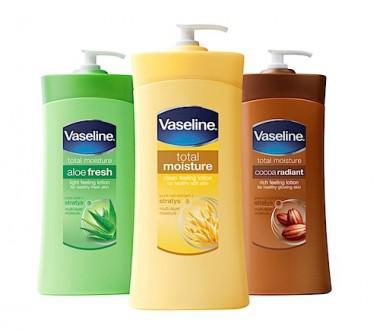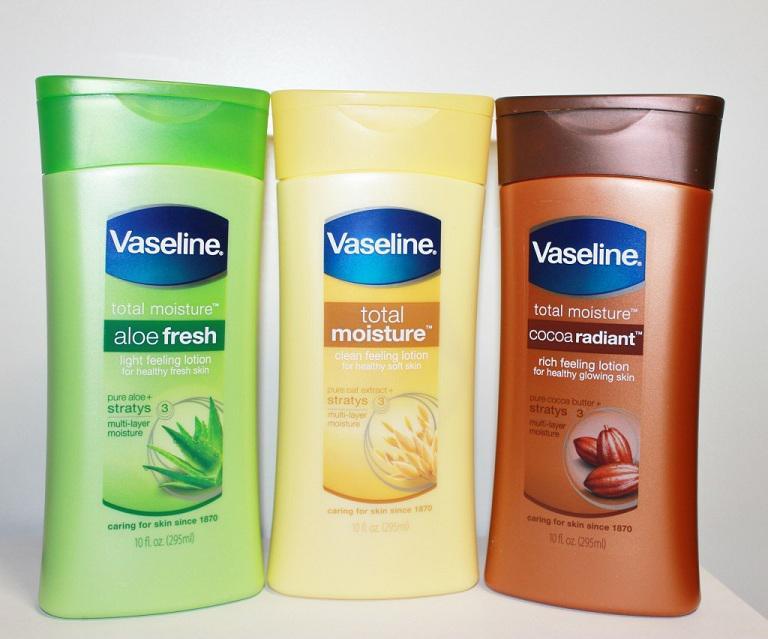The first image is the image on the left, the second image is the image on the right. For the images shown, is this caption "Lotions are in groups of three with flip-top lids." true? Answer yes or no. No. 